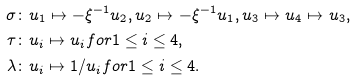Convert formula to latex. <formula><loc_0><loc_0><loc_500><loc_500>\sigma \colon & u _ { 1 } \mapsto - \xi ^ { - 1 } u _ { 2 } , u _ { 2 } \mapsto - \xi ^ { - 1 } u _ { 1 } , u _ { 3 } \mapsto u _ { 4 } \mapsto u _ { 3 } , \\ \tau \colon & u _ { i } \mapsto u _ { i } f o r 1 \leq i \leq 4 , \\ \lambda \colon & u _ { i } \mapsto 1 / u _ { i } f o r 1 \leq i \leq 4 .</formula> 